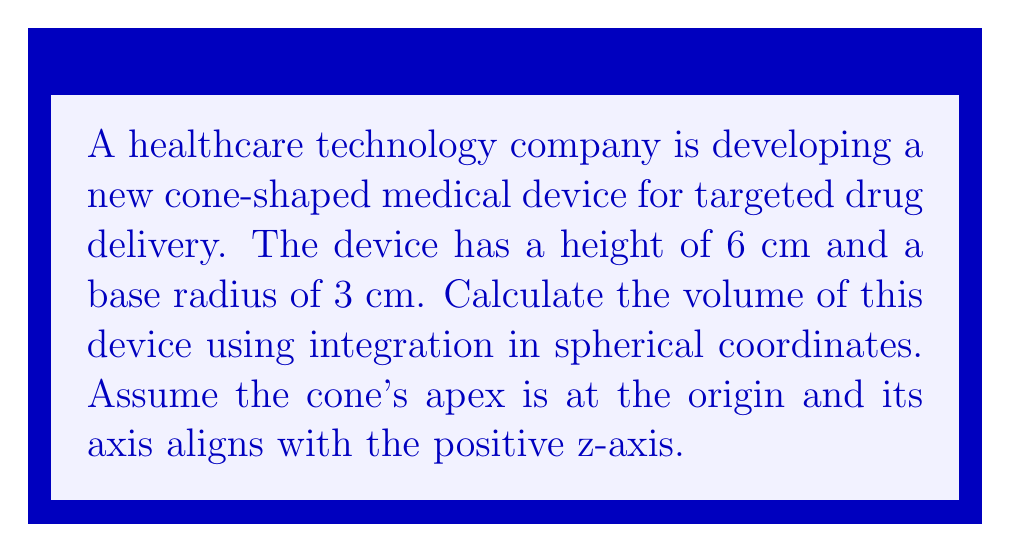Show me your answer to this math problem. To solve this problem, we'll follow these steps:

1) In spherical coordinates, we have:
   $x = r\sin\theta\cos\phi$
   $y = r\sin\theta\sin\phi$
   $z = r\cos\theta$

2) The equation of a cone with apex at the origin, axis along the z-axis, and half-angle $\alpha$ is:
   $z = r\cos\alpha$

3) We need to find $\alpha$. In our cone:
   $\tan\alpha = \frac{\text{base radius}}{\text{height}} = \frac{3}{6} = \frac{1}{2}$
   $\alpha = \arctan(\frac{1}{2}) \approx 0.4636$ radians

4) The volume in spherical coordinates is given by:
   $$V = \int_{\phi=0}^{2\pi} \int_{\theta=0}^{\alpha} \int_{r=0}^{R(\theta)} r^2 \sin\theta \, dr \, d\theta \, d\phi$$

   where $R(\theta)$ is the distance from the origin to the surface of the cone.

5) To find $R(\theta)$, we use:
   $\cos\alpha = \frac{z}{r} = \cos\theta$
   So, $R(\theta) = \frac{6}{\cos\theta}$

6) Now we can set up our integral:
   $$V = \int_{0}^{2\pi} \int_{0}^{\alpha} \int_{0}^{\frac{6}{\cos\theta}} r^2 \sin\theta \, dr \, d\theta \, d\phi$$

7) Integrating with respect to r:
   $$V = \int_{0}^{2\pi} \int_{0}^{\alpha} \frac{1}{3} \left(\frac{6}{\cos\theta}\right)^3 \sin\theta \, d\theta \, d\phi$$

8) Simplify:
   $$V = 72\pi \int_{0}^{\alpha} \frac{\sin\theta}{\cos^3\theta} \, d\theta$$

9) Use the substitution $u = \cos\theta$, $du = -\sin\theta \, d\theta$:
   $$V = -72\pi \int_{\cos\alpha}^{1} \frac{1}{u^3} \, du$$

10) Integrate:
    $$V = 72\pi \left[ \frac{1}{2u^2} \right]_{\cos\alpha}^{1}$$

11) Substitute back:
    $$V = 72\pi \left( \frac{1}{2} - \frac{1}{2\cos^2\alpha} \right)$$

12) Recall $\cos\alpha = \frac{6}{\sqrt{36+9}} = \frac{2}{\sqrt{5}}$

13) Substitute and simplify:
    $$V = 72\pi \left( \frac{1}{2} - \frac{5}{8} \right) = 72\pi \cdot \frac{-1}{8} = -9\pi$$

14) The volume is the absolute value of this:
    $$V = 9\pi \text{ cm}^3$$
Answer: $9\pi \text{ cm}^3 \approx 28.27 \text{ cm}^3$ 